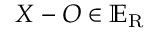<formula> <loc_0><loc_0><loc_500><loc_500>X - O \in \mathbb { E } _ { R }</formula> 